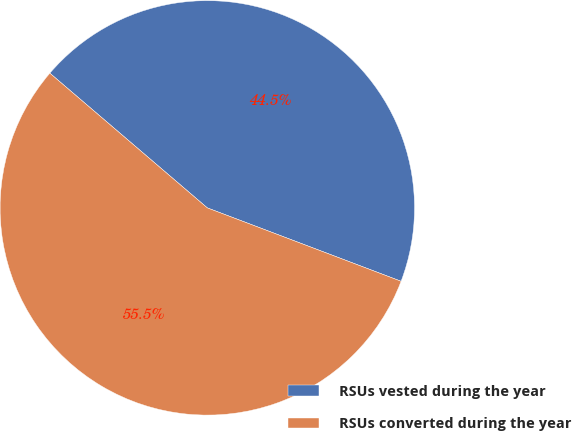Convert chart. <chart><loc_0><loc_0><loc_500><loc_500><pie_chart><fcel>RSUs vested during the year<fcel>RSUs converted during the year<nl><fcel>44.5%<fcel>55.5%<nl></chart> 